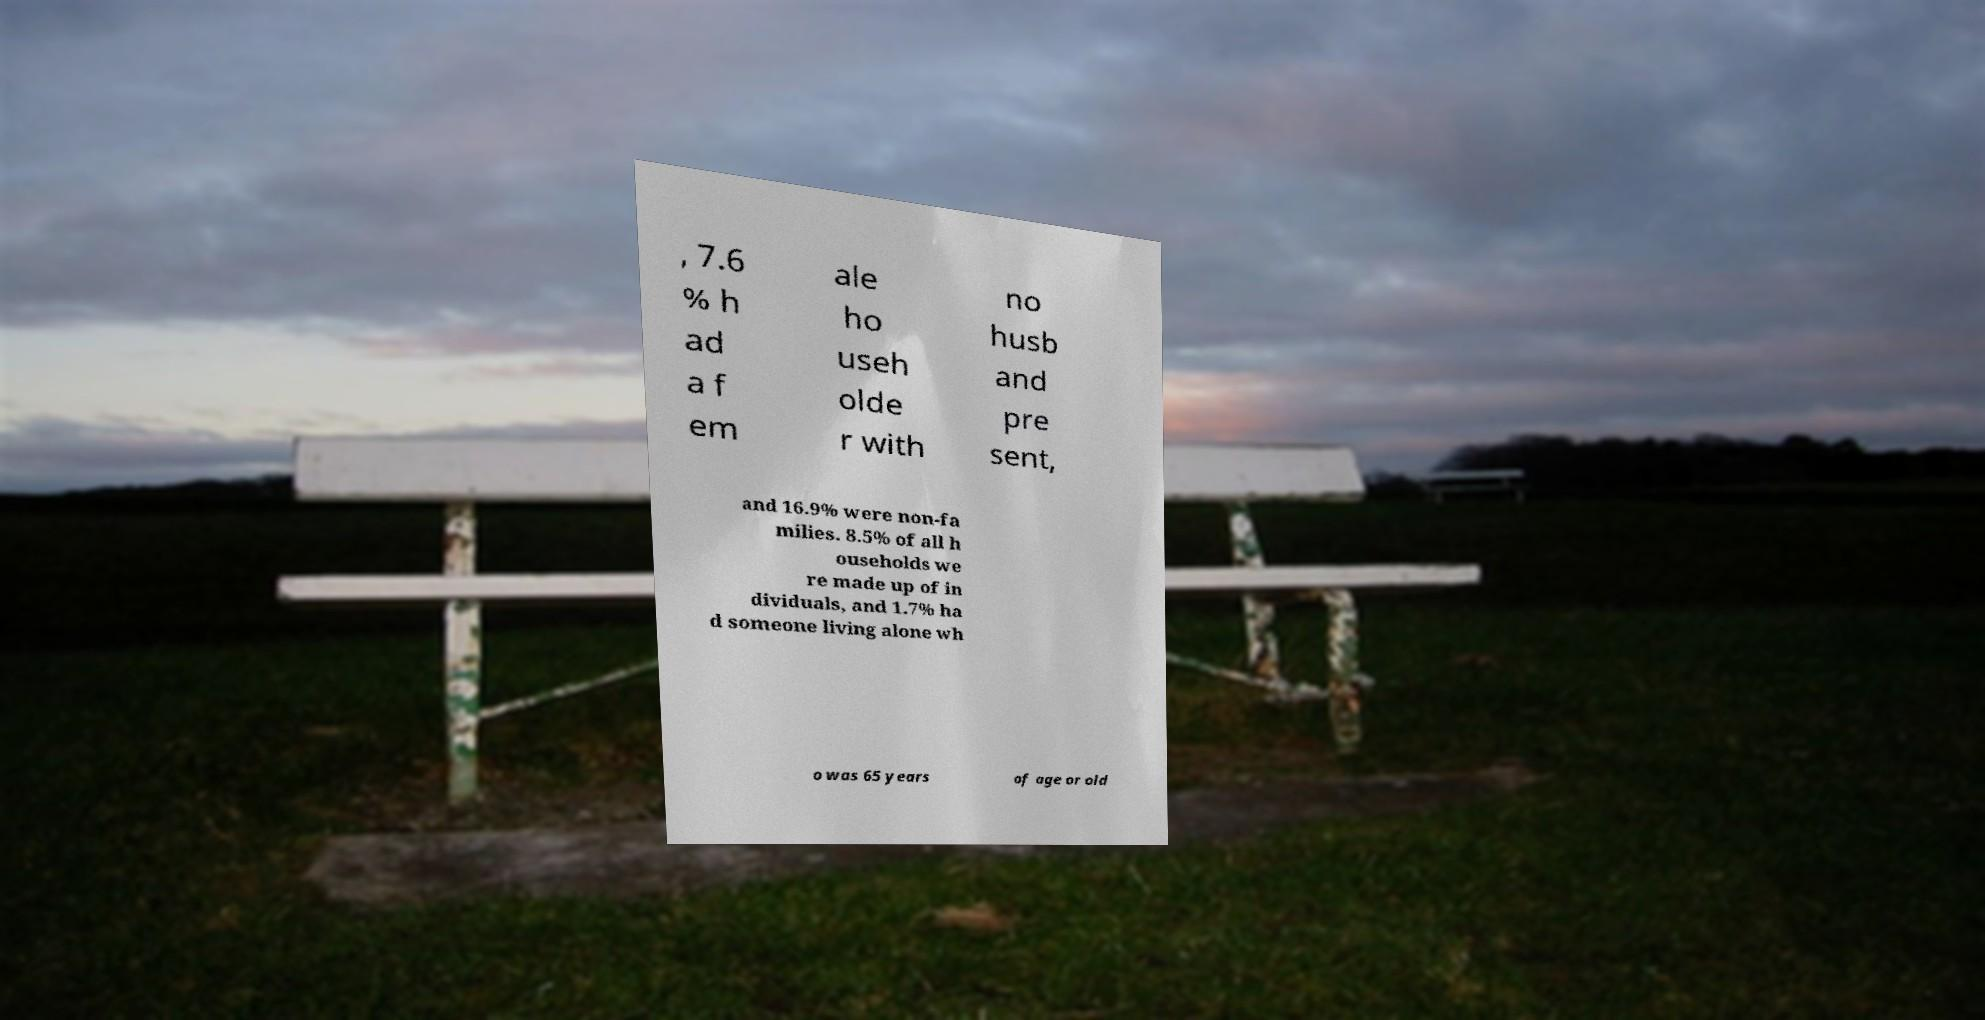Please identify and transcribe the text found in this image. , 7.6 % h ad a f em ale ho useh olde r with no husb and pre sent, and 16.9% were non-fa milies. 8.5% of all h ouseholds we re made up of in dividuals, and 1.7% ha d someone living alone wh o was 65 years of age or old 